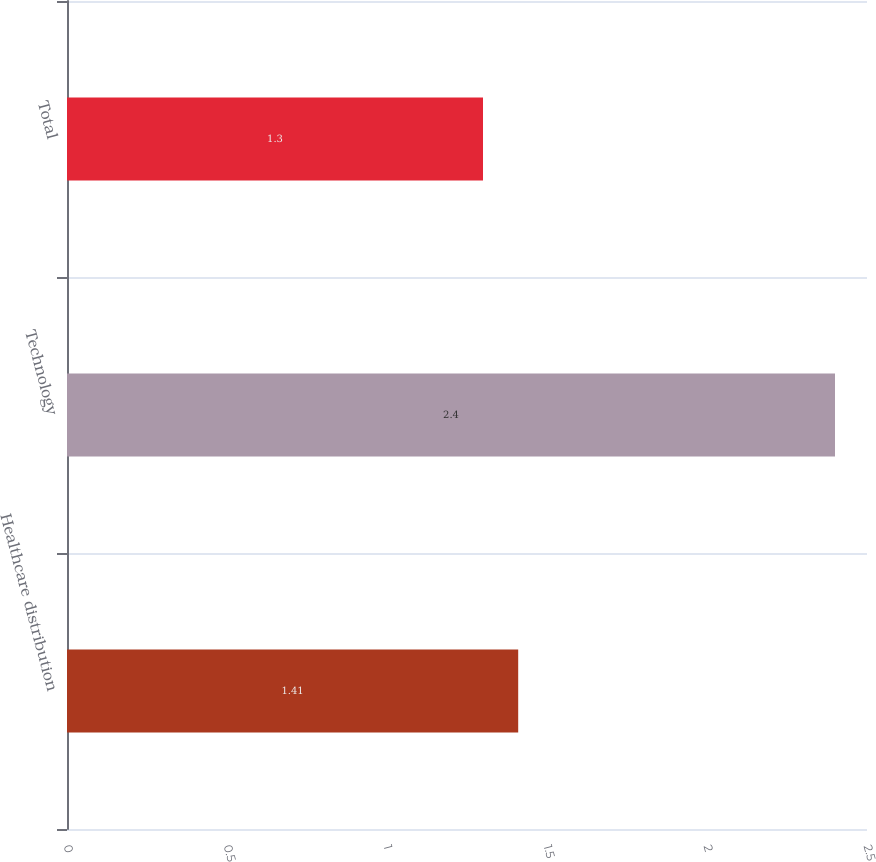<chart> <loc_0><loc_0><loc_500><loc_500><bar_chart><fcel>Healthcare distribution<fcel>Technology<fcel>Total<nl><fcel>1.41<fcel>2.4<fcel>1.3<nl></chart> 